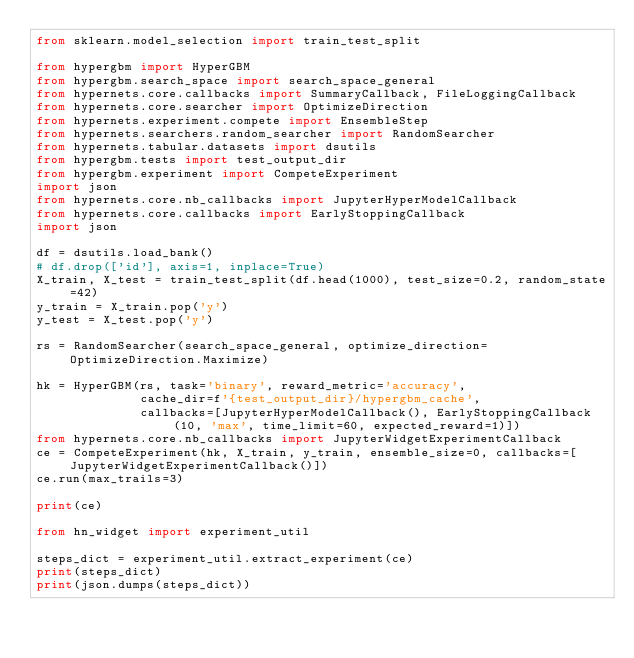Convert code to text. <code><loc_0><loc_0><loc_500><loc_500><_Python_>from sklearn.model_selection import train_test_split

from hypergbm import HyperGBM
from hypergbm.search_space import search_space_general
from hypernets.core.callbacks import SummaryCallback, FileLoggingCallback
from hypernets.core.searcher import OptimizeDirection
from hypernets.experiment.compete import EnsembleStep
from hypernets.searchers.random_searcher import RandomSearcher
from hypernets.tabular.datasets import dsutils
from hypergbm.tests import test_output_dir
from hypergbm.experiment import CompeteExperiment
import json
from hypernets.core.nb_callbacks import JupyterHyperModelCallback
from hypernets.core.callbacks import EarlyStoppingCallback
import json

df = dsutils.load_bank()
# df.drop(['id'], axis=1, inplace=True)
X_train, X_test = train_test_split(df.head(1000), test_size=0.2, random_state=42)
y_train = X_train.pop('y')
y_test = X_test.pop('y')

rs = RandomSearcher(search_space_general, optimize_direction=OptimizeDirection.Maximize)

hk = HyperGBM(rs, task='binary', reward_metric='accuracy',
              cache_dir=f'{test_output_dir}/hypergbm_cache',
              callbacks=[JupyterHyperModelCallback(), EarlyStoppingCallback(10, 'max', time_limit=60, expected_reward=1)])
from hypernets.core.nb_callbacks import JupyterWidgetExperimentCallback
ce = CompeteExperiment(hk, X_train, y_train, ensemble_size=0, callbacks=[JupyterWidgetExperimentCallback()])
ce.run(max_trails=3)

print(ce)

from hn_widget import experiment_util

steps_dict = experiment_util.extract_experiment(ce)
print(steps_dict)
print(json.dumps(steps_dict))
</code> 